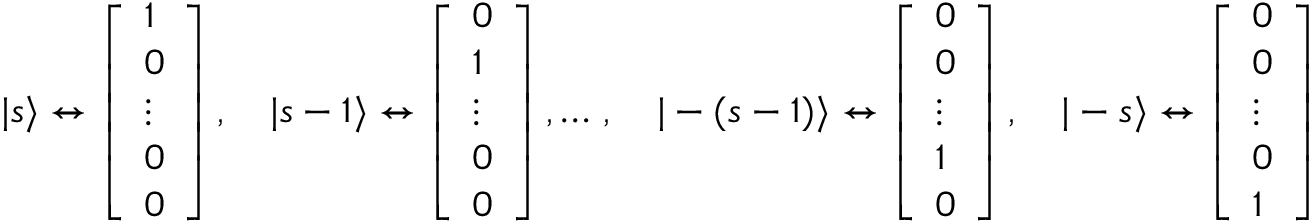<formula> <loc_0><loc_0><loc_500><loc_500>| s \rangle \leftrightarrow { \left [ \begin{array} { l } { 1 } \\ { 0 } \\ { \vdots } \\ { 0 } \\ { 0 } \end{array} \right ] } \, , \quad | s - 1 \rangle \leftrightarrow { \left [ \begin{array} { l } { 0 } \\ { 1 } \\ { \vdots } \\ { 0 } \\ { 0 } \end{array} \right ] } \, , \dots \, , \quad | - ( s - 1 ) \rangle \leftrightarrow { \left [ \begin{array} { l } { 0 } \\ { 0 } \\ { \vdots } \\ { 1 } \\ { 0 } \end{array} \right ] } \, , \quad | - s \rangle \leftrightarrow { \left [ \begin{array} { l } { 0 } \\ { 0 } \\ { \vdots } \\ { 0 } \\ { 1 } \end{array} \right ] }</formula> 